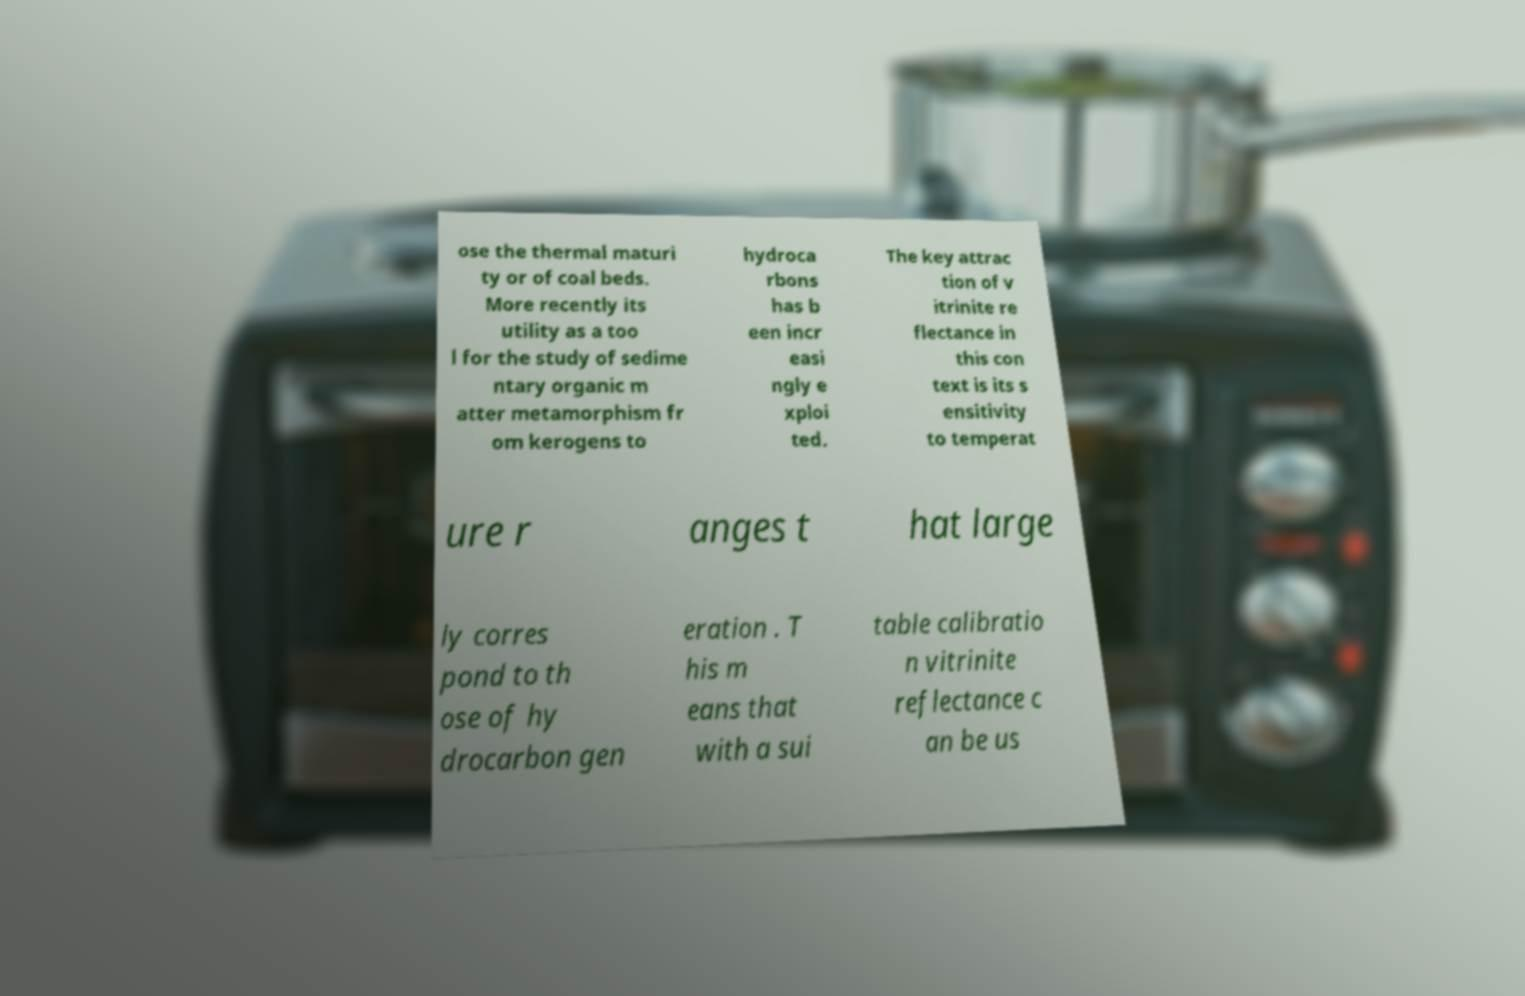Please read and relay the text visible in this image. What does it say? ose the thermal maturi ty or of coal beds. More recently its utility as a too l for the study of sedime ntary organic m atter metamorphism fr om kerogens to hydroca rbons has b een incr easi ngly e xploi ted. The key attrac tion of v itrinite re flectance in this con text is its s ensitivity to temperat ure r anges t hat large ly corres pond to th ose of hy drocarbon gen eration . T his m eans that with a sui table calibratio n vitrinite reflectance c an be us 